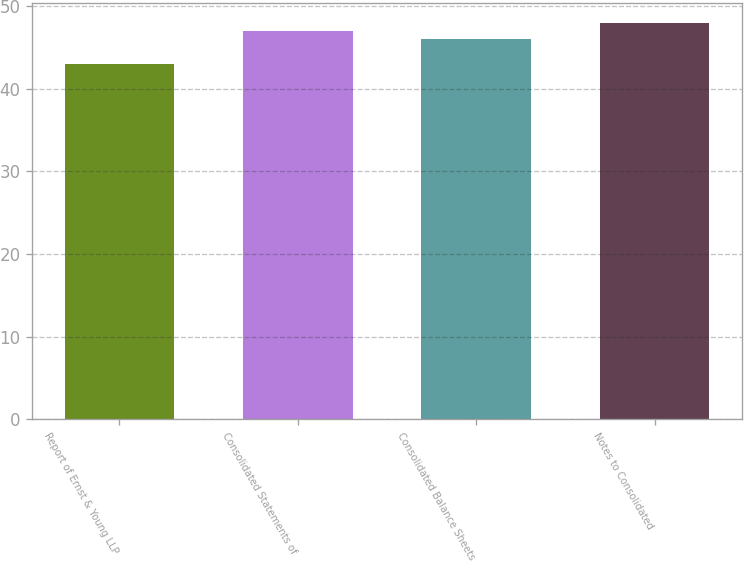Convert chart to OTSL. <chart><loc_0><loc_0><loc_500><loc_500><bar_chart><fcel>Report of Ernst & Young LLP<fcel>Consolidated Statements of<fcel>Consolidated Balance Sheets<fcel>Notes to Consolidated<nl><fcel>43<fcel>47<fcel>46<fcel>48<nl></chart> 